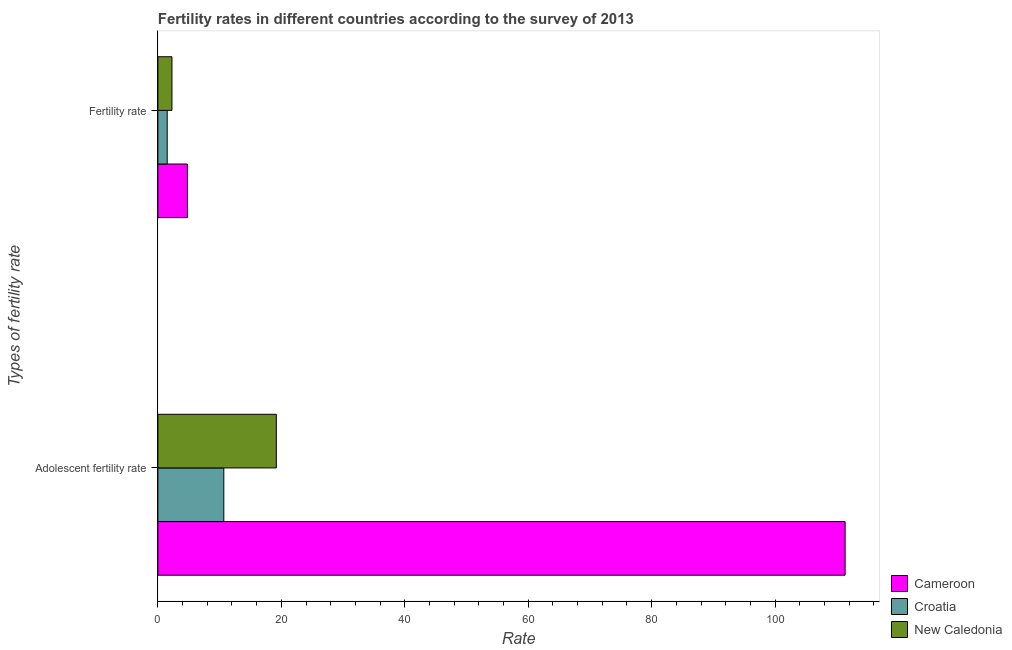How many different coloured bars are there?
Offer a very short reply. 3. How many groups of bars are there?
Provide a short and direct response. 2. Are the number of bars per tick equal to the number of legend labels?
Your answer should be compact. Yes. Are the number of bars on each tick of the Y-axis equal?
Your response must be concise. Yes. How many bars are there on the 2nd tick from the top?
Make the answer very short. 3. What is the label of the 2nd group of bars from the top?
Your answer should be compact. Adolescent fertility rate. What is the adolescent fertility rate in New Caledonia?
Keep it short and to the point. 19.19. Across all countries, what is the maximum adolescent fertility rate?
Your response must be concise. 111.35. Across all countries, what is the minimum fertility rate?
Give a very brief answer. 1.51. In which country was the fertility rate maximum?
Offer a terse response. Cameroon. In which country was the fertility rate minimum?
Give a very brief answer. Croatia. What is the total fertility rate in the graph?
Make the answer very short. 8.57. What is the difference between the adolescent fertility rate in New Caledonia and that in Cameroon?
Your answer should be compact. -92.16. What is the difference between the fertility rate in New Caledonia and the adolescent fertility rate in Cameroon?
Keep it short and to the point. -109.07. What is the average adolescent fertility rate per country?
Provide a succinct answer. 47.07. What is the difference between the fertility rate and adolescent fertility rate in Croatia?
Your answer should be very brief. -9.17. What is the ratio of the fertility rate in New Caledonia to that in Croatia?
Offer a terse response. 1.51. Is the adolescent fertility rate in New Caledonia less than that in Croatia?
Offer a very short reply. No. In how many countries, is the fertility rate greater than the average fertility rate taken over all countries?
Your answer should be very brief. 1. What does the 1st bar from the top in Fertility rate represents?
Keep it short and to the point. New Caledonia. What does the 2nd bar from the bottom in Fertility rate represents?
Provide a succinct answer. Croatia. How many bars are there?
Offer a terse response. 6. Are all the bars in the graph horizontal?
Offer a terse response. Yes. How many countries are there in the graph?
Offer a very short reply. 3. Does the graph contain any zero values?
Your response must be concise. No. Does the graph contain grids?
Offer a terse response. No. Where does the legend appear in the graph?
Offer a very short reply. Bottom right. How many legend labels are there?
Your response must be concise. 3. How are the legend labels stacked?
Ensure brevity in your answer.  Vertical. What is the title of the graph?
Offer a very short reply. Fertility rates in different countries according to the survey of 2013. What is the label or title of the X-axis?
Your answer should be very brief. Rate. What is the label or title of the Y-axis?
Provide a short and direct response. Types of fertility rate. What is the Rate in Cameroon in Adolescent fertility rate?
Provide a short and direct response. 111.35. What is the Rate of Croatia in Adolescent fertility rate?
Provide a short and direct response. 10.68. What is the Rate of New Caledonia in Adolescent fertility rate?
Provide a short and direct response. 19.19. What is the Rate in Cameroon in Fertility rate?
Provide a succinct answer. 4.78. What is the Rate of Croatia in Fertility rate?
Your response must be concise. 1.51. What is the Rate in New Caledonia in Fertility rate?
Your answer should be compact. 2.28. Across all Types of fertility rate, what is the maximum Rate in Cameroon?
Keep it short and to the point. 111.35. Across all Types of fertility rate, what is the maximum Rate in Croatia?
Make the answer very short. 10.68. Across all Types of fertility rate, what is the maximum Rate of New Caledonia?
Ensure brevity in your answer.  19.19. Across all Types of fertility rate, what is the minimum Rate in Cameroon?
Make the answer very short. 4.78. Across all Types of fertility rate, what is the minimum Rate of Croatia?
Your answer should be very brief. 1.51. Across all Types of fertility rate, what is the minimum Rate of New Caledonia?
Keep it short and to the point. 2.28. What is the total Rate in Cameroon in the graph?
Your answer should be compact. 116.13. What is the total Rate in Croatia in the graph?
Provide a succinct answer. 12.19. What is the total Rate in New Caledonia in the graph?
Your response must be concise. 21.47. What is the difference between the Rate of Cameroon in Adolescent fertility rate and that in Fertility rate?
Your answer should be very brief. 106.56. What is the difference between the Rate of Croatia in Adolescent fertility rate and that in Fertility rate?
Offer a terse response. 9.17. What is the difference between the Rate in New Caledonia in Adolescent fertility rate and that in Fertility rate?
Provide a short and direct response. 16.91. What is the difference between the Rate in Cameroon in Adolescent fertility rate and the Rate in Croatia in Fertility rate?
Offer a very short reply. 109.84. What is the difference between the Rate in Cameroon in Adolescent fertility rate and the Rate in New Caledonia in Fertility rate?
Ensure brevity in your answer.  109.07. What is the average Rate of Cameroon per Types of fertility rate?
Your answer should be compact. 58.06. What is the average Rate of Croatia per Types of fertility rate?
Offer a terse response. 6.09. What is the average Rate in New Caledonia per Types of fertility rate?
Provide a succinct answer. 10.73. What is the difference between the Rate in Cameroon and Rate in Croatia in Adolescent fertility rate?
Your response must be concise. 100.67. What is the difference between the Rate of Cameroon and Rate of New Caledonia in Adolescent fertility rate?
Your response must be concise. 92.16. What is the difference between the Rate in Croatia and Rate in New Caledonia in Adolescent fertility rate?
Your answer should be compact. -8.51. What is the difference between the Rate of Cameroon and Rate of Croatia in Fertility rate?
Offer a terse response. 3.27. What is the difference between the Rate in Cameroon and Rate in New Caledonia in Fertility rate?
Offer a terse response. 2.5. What is the difference between the Rate in Croatia and Rate in New Caledonia in Fertility rate?
Your answer should be very brief. -0.77. What is the ratio of the Rate in Cameroon in Adolescent fertility rate to that in Fertility rate?
Your answer should be compact. 23.29. What is the ratio of the Rate in Croatia in Adolescent fertility rate to that in Fertility rate?
Provide a short and direct response. 7.07. What is the ratio of the Rate of New Caledonia in Adolescent fertility rate to that in Fertility rate?
Your response must be concise. 8.42. What is the difference between the highest and the second highest Rate of Cameroon?
Provide a succinct answer. 106.56. What is the difference between the highest and the second highest Rate of Croatia?
Ensure brevity in your answer.  9.17. What is the difference between the highest and the second highest Rate in New Caledonia?
Offer a very short reply. 16.91. What is the difference between the highest and the lowest Rate in Cameroon?
Offer a terse response. 106.56. What is the difference between the highest and the lowest Rate in Croatia?
Give a very brief answer. 9.17. What is the difference between the highest and the lowest Rate of New Caledonia?
Provide a succinct answer. 16.91. 